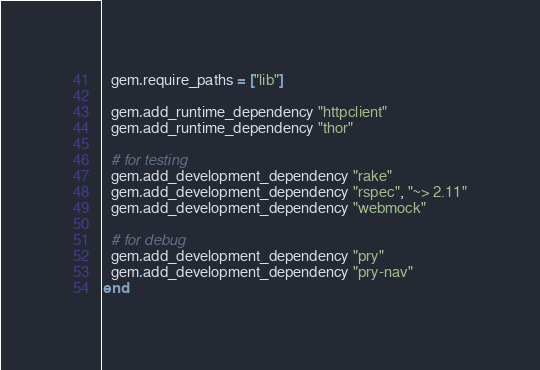<code> <loc_0><loc_0><loc_500><loc_500><_Ruby_>  gem.require_paths = ["lib"]

  gem.add_runtime_dependency "httpclient"
  gem.add_runtime_dependency "thor"

  # for testing
  gem.add_development_dependency "rake"
  gem.add_development_dependency "rspec", "~> 2.11"
  gem.add_development_dependency "webmock"

  # for debug
  gem.add_development_dependency "pry"
  gem.add_development_dependency "pry-nav"
end
</code> 